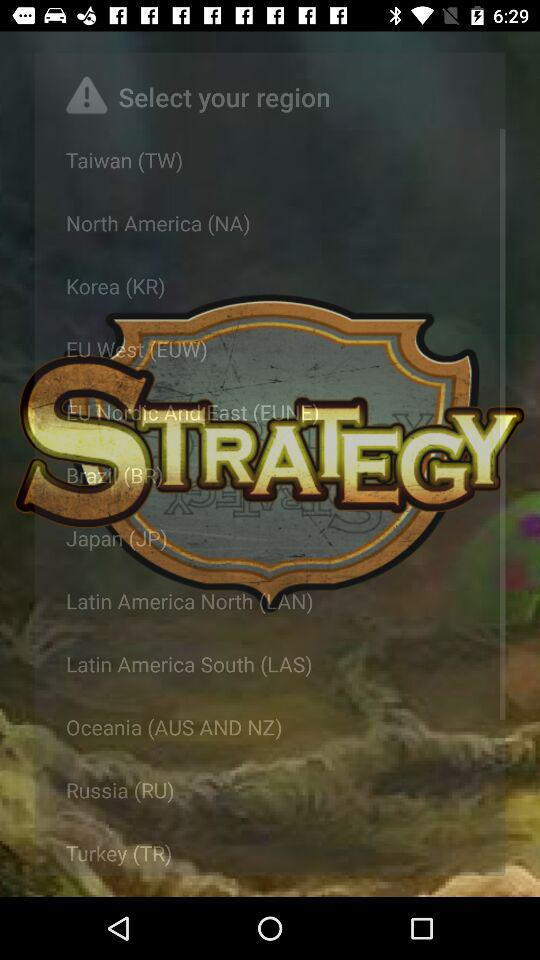What is the application name?
When the provided information is insufficient, respond with <no answer>. <no answer> 